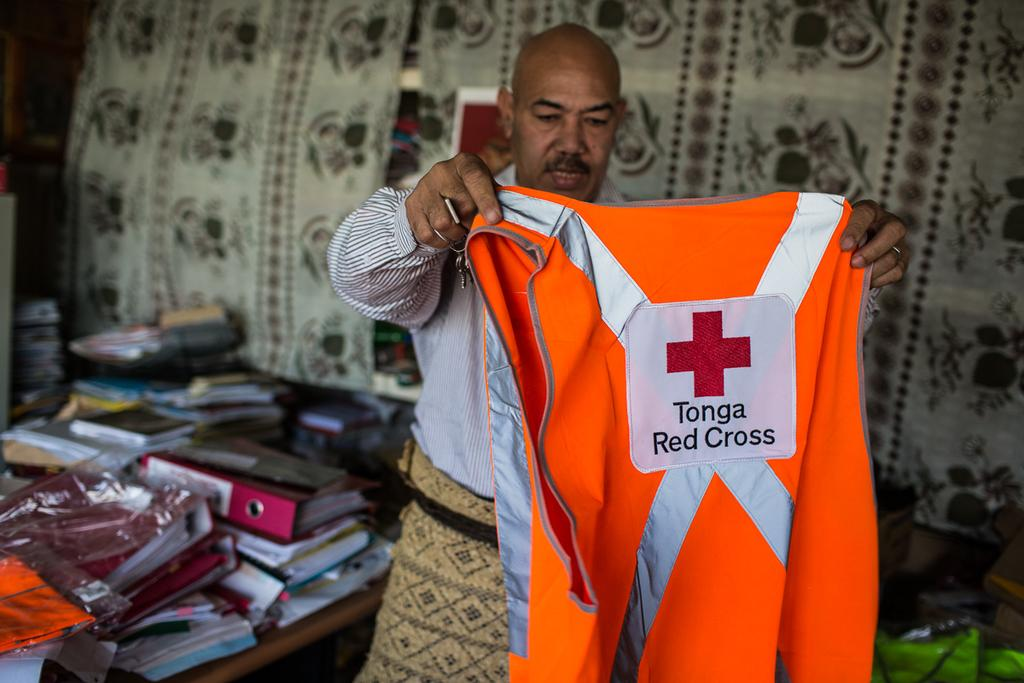<image>
Render a clear and concise summary of the photo. A man holds up an orange safety vest for Tonga Red Cross. 